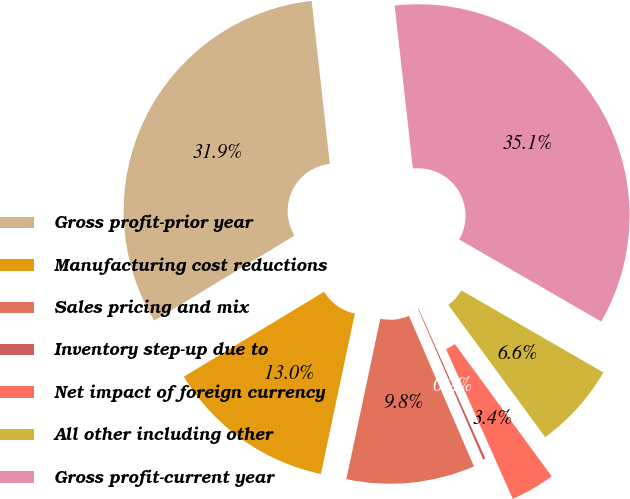<chart> <loc_0><loc_0><loc_500><loc_500><pie_chart><fcel>Gross profit-prior year<fcel>Manufacturing cost reductions<fcel>Sales pricing and mix<fcel>Inventory step-up due to<fcel>Net impact of foreign currency<fcel>All other including other<fcel>Gross profit-current year<nl><fcel>31.9%<fcel>13.01%<fcel>9.81%<fcel>0.18%<fcel>3.39%<fcel>6.6%<fcel>35.11%<nl></chart> 